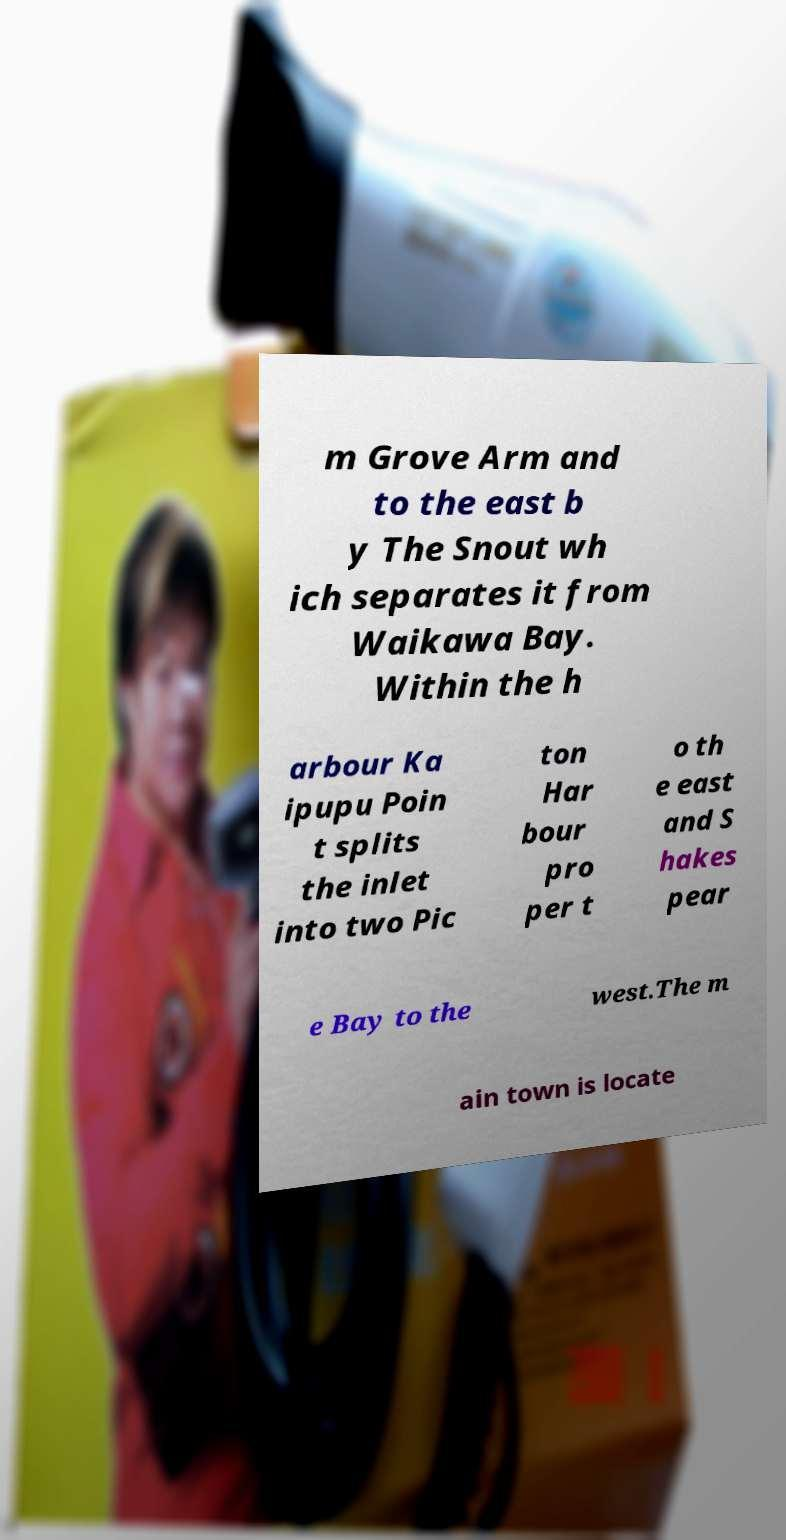I need the written content from this picture converted into text. Can you do that? m Grove Arm and to the east b y The Snout wh ich separates it from Waikawa Bay. Within the h arbour Ka ipupu Poin t splits the inlet into two Pic ton Har bour pro per t o th e east and S hakes pear e Bay to the west.The m ain town is locate 